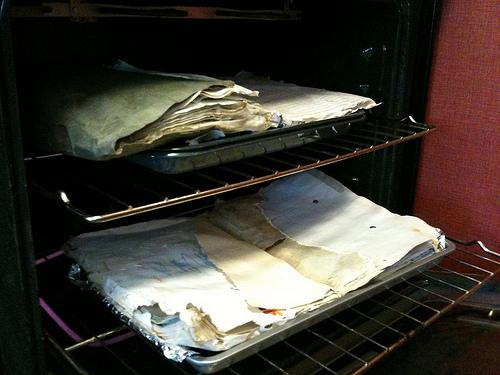For visual entailment task, what objects can be found in the oven besides the racks? There are silver pans, trays with spiral notebooks, a heater coil, and food wrapped in papers and foil. For the visual entailment task, describe one observation about the oven. The oven has two silver oven racks in it, one on the top and one on the bottom. Can you spot any foil in the image? Where is it placed? Yes, there is aluminum foil on the bottom pan. For the multi-choice VQA task, what kind of trays can be found in the image? There are two silver or grey color trays stacked together, filled with contents and put together. In a multi-choice VQA task, what color is the wall in the image? The wall is burgundy or brick red color. In the image, what is most likely to be happening with food? Food is being cooked on a rack, with papers and foil wrapped around it. For product advertisement task, describe the appearance of the oven rack and coil in the image. The oven rack is silver-colored, and the heater coil is light purple when lit up, providing efficient heating for cooking. 